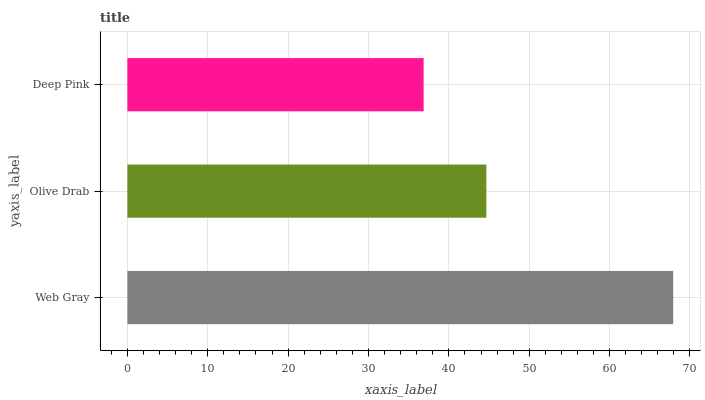Is Deep Pink the minimum?
Answer yes or no. Yes. Is Web Gray the maximum?
Answer yes or no. Yes. Is Olive Drab the minimum?
Answer yes or no. No. Is Olive Drab the maximum?
Answer yes or no. No. Is Web Gray greater than Olive Drab?
Answer yes or no. Yes. Is Olive Drab less than Web Gray?
Answer yes or no. Yes. Is Olive Drab greater than Web Gray?
Answer yes or no. No. Is Web Gray less than Olive Drab?
Answer yes or no. No. Is Olive Drab the high median?
Answer yes or no. Yes. Is Olive Drab the low median?
Answer yes or no. Yes. Is Deep Pink the high median?
Answer yes or no. No. Is Web Gray the low median?
Answer yes or no. No. 